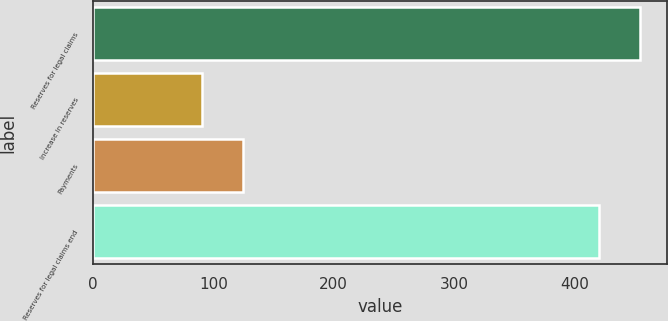<chart> <loc_0><loc_0><loc_500><loc_500><bar_chart><fcel>Reserves for legal claims<fcel>Increase in reserves<fcel>Payments<fcel>Reserves for legal claims end<nl><fcel>453.85<fcel>91<fcel>124.25<fcel>420.6<nl></chart> 